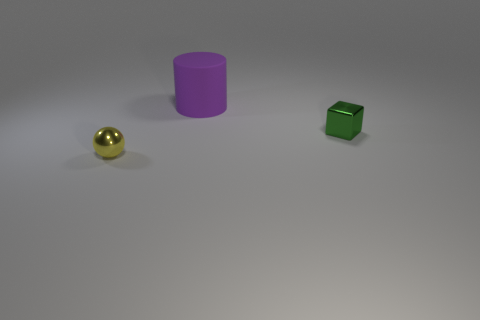Subtract all gray cylinders. Subtract all gray blocks. How many cylinders are left? 1 Add 2 small yellow balls. How many objects exist? 5 Subtract all cubes. How many objects are left? 2 Subtract 0 red balls. How many objects are left? 3 Subtract all large matte blocks. Subtract all cubes. How many objects are left? 2 Add 2 tiny green objects. How many tiny green objects are left? 3 Add 2 tiny yellow metal things. How many tiny yellow metal things exist? 3 